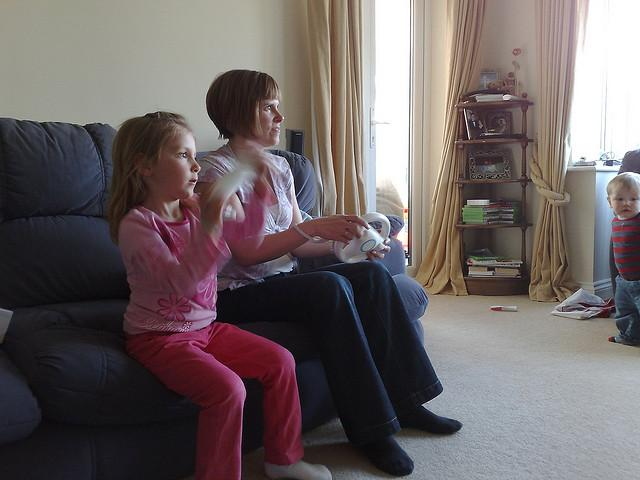What are the people on the couch looking at? television 